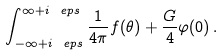<formula> <loc_0><loc_0><loc_500><loc_500>\int _ { - \infty + i \ e p s } ^ { \infty + i \ e p s } \frac { 1 } { 4 \pi } f ( \theta ) + \frac { G } { 4 } \varphi ( 0 ) \, .</formula> 